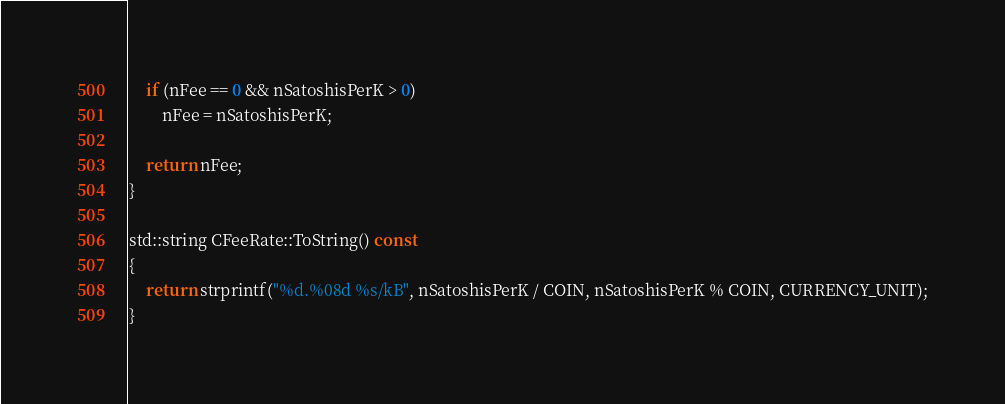Convert code to text. <code><loc_0><loc_0><loc_500><loc_500><_C++_>    if (nFee == 0 && nSatoshisPerK > 0)
        nFee = nSatoshisPerK;

    return nFee;
}

std::string CFeeRate::ToString() const
{
    return strprintf("%d.%08d %s/kB", nSatoshisPerK / COIN, nSatoshisPerK % COIN, CURRENCY_UNIT);
}
</code> 